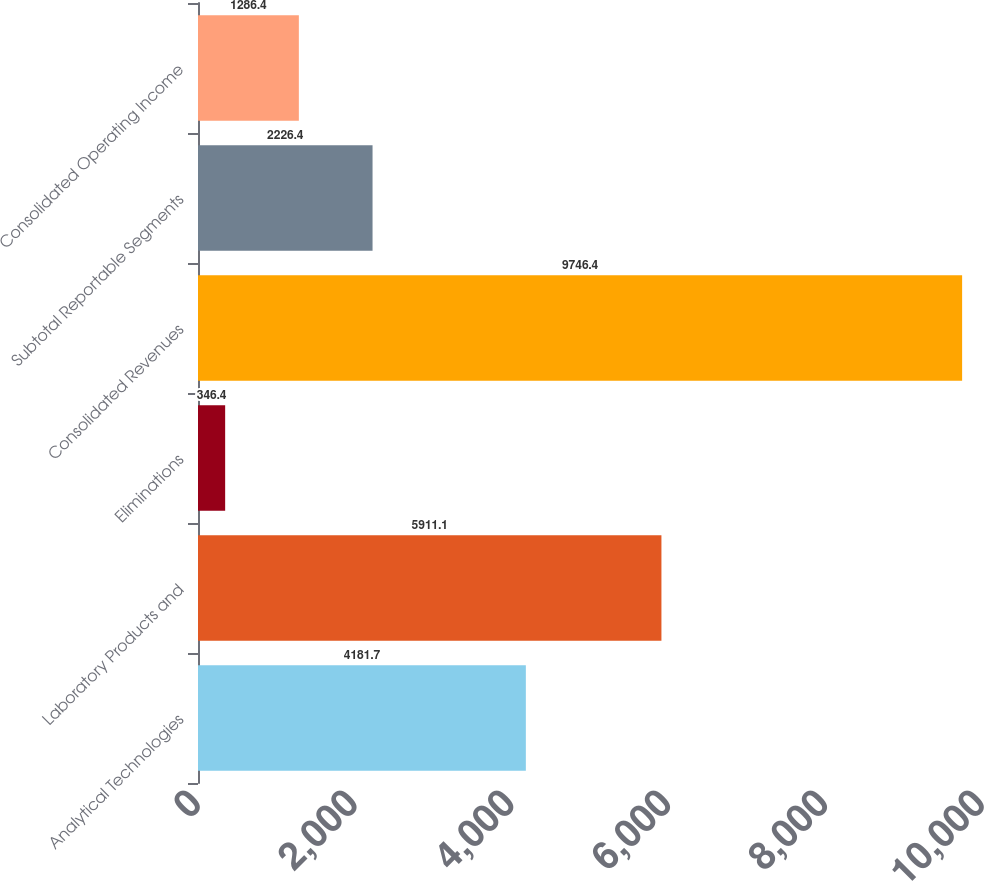Convert chart. <chart><loc_0><loc_0><loc_500><loc_500><bar_chart><fcel>Analytical Technologies<fcel>Laboratory Products and<fcel>Eliminations<fcel>Consolidated Revenues<fcel>Subtotal Reportable Segments<fcel>Consolidated Operating Income<nl><fcel>4181.7<fcel>5911.1<fcel>346.4<fcel>9746.4<fcel>2226.4<fcel>1286.4<nl></chart> 